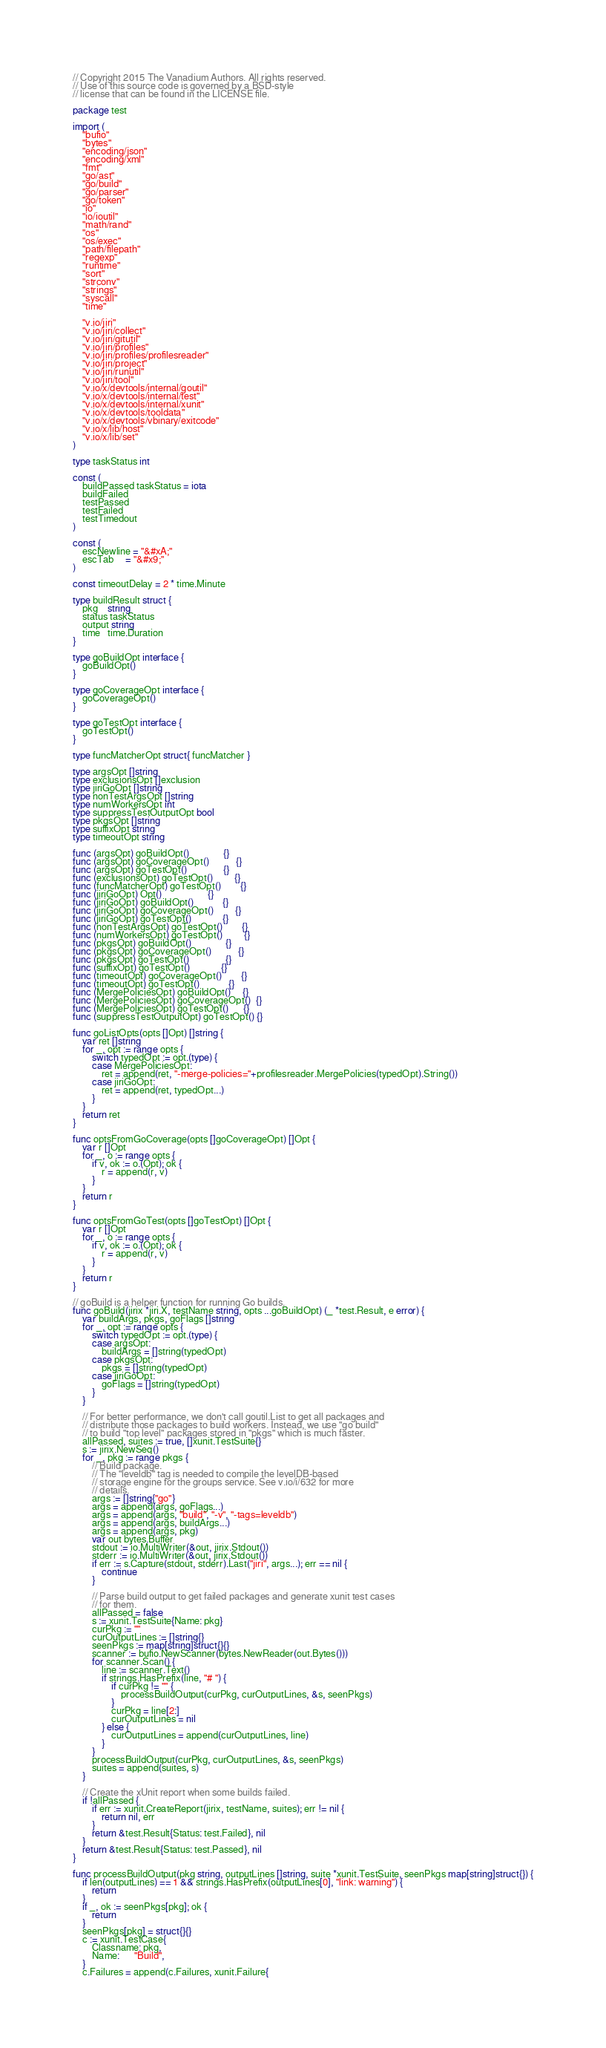<code> <loc_0><loc_0><loc_500><loc_500><_Go_>// Copyright 2015 The Vanadium Authors. All rights reserved.
// Use of this source code is governed by a BSD-style
// license that can be found in the LICENSE file.

package test

import (
	"bufio"
	"bytes"
	"encoding/json"
	"encoding/xml"
	"fmt"
	"go/ast"
	"go/build"
	"go/parser"
	"go/token"
	"io"
	"io/ioutil"
	"math/rand"
	"os"
	"os/exec"
	"path/filepath"
	"regexp"
	"runtime"
	"sort"
	"strconv"
	"strings"
	"syscall"
	"time"

	"v.io/jiri"
	"v.io/jiri/collect"
	"v.io/jiri/gitutil"
	"v.io/jiri/profiles"
	"v.io/jiri/profiles/profilesreader"
	"v.io/jiri/project"
	"v.io/jiri/runutil"
	"v.io/jiri/tool"
	"v.io/x/devtools/internal/goutil"
	"v.io/x/devtools/internal/test"
	"v.io/x/devtools/internal/xunit"
	"v.io/x/devtools/tooldata"
	"v.io/x/devtools/vbinary/exitcode"
	"v.io/x/lib/host"
	"v.io/x/lib/set"
)

type taskStatus int

const (
	buildPassed taskStatus = iota
	buildFailed
	testPassed
	testFailed
	testTimedout
)

const (
	escNewline = "&#xA;"
	escTab     = "&#x9;"
)

const timeoutDelay = 2 * time.Minute

type buildResult struct {
	pkg    string
	status taskStatus
	output string
	time   time.Duration
}

type goBuildOpt interface {
	goBuildOpt()
}

type goCoverageOpt interface {
	goCoverageOpt()
}

type goTestOpt interface {
	goTestOpt()
}

type funcMatcherOpt struct{ funcMatcher }

type argsOpt []string
type exclusionsOpt []exclusion
type jiriGoOpt []string
type nonTestArgsOpt []string
type numWorkersOpt int
type suppressTestOutputOpt bool
type pkgsOpt []string
type suffixOpt string
type timeoutOpt string

func (argsOpt) goBuildOpt()              {}
func (argsOpt) goCoverageOpt()           {}
func (argsOpt) goTestOpt()               {}
func (exclusionsOpt) goTestOpt()         {}
func (funcMatcherOpt) goTestOpt()        {}
func (jiriGoOpt) Opt()                   {}
func (jiriGoOpt) goBuildOpt()            {}
func (jiriGoOpt) goCoverageOpt()         {}
func (jiriGoOpt) goTestOpt()             {}
func (nonTestArgsOpt) goTestOpt()        {}
func (numWorkersOpt) goTestOpt()         {}
func (pkgsOpt) goBuildOpt()              {}
func (pkgsOpt) goCoverageOpt()           {}
func (pkgsOpt) goTestOpt()               {}
func (suffixOpt) goTestOpt()             {}
func (timeoutOpt) goCoverageOpt()        {}
func (timeoutOpt) goTestOpt()            {}
func (MergePoliciesOpt) goBuildOpt()     {}
func (MergePoliciesOpt) goCoverageOpt()  {}
func (MergePoliciesOpt) goTestOpt()      {}
func (suppressTestOutputOpt) goTestOpt() {}

func goListOpts(opts []Opt) []string {
	var ret []string
	for _, opt := range opts {
		switch typedOpt := opt.(type) {
		case MergePoliciesOpt:
			ret = append(ret, "-merge-policies="+profilesreader.MergePolicies(typedOpt).String())
		case jiriGoOpt:
			ret = append(ret, typedOpt...)
		}
	}
	return ret
}

func optsFromGoCoverage(opts []goCoverageOpt) []Opt {
	var r []Opt
	for _, o := range opts {
		if v, ok := o.(Opt); ok {
			r = append(r, v)
		}
	}
	return r
}

func optsFromGoTest(opts []goTestOpt) []Opt {
	var r []Opt
	for _, o := range opts {
		if v, ok := o.(Opt); ok {
			r = append(r, v)
		}
	}
	return r
}

// goBuild is a helper function for running Go builds.
func goBuild(jirix *jiri.X, testName string, opts ...goBuildOpt) (_ *test.Result, e error) {
	var buildArgs, pkgs, goFlags []string
	for _, opt := range opts {
		switch typedOpt := opt.(type) {
		case argsOpt:
			buildArgs = []string(typedOpt)
		case pkgsOpt:
			pkgs = []string(typedOpt)
		case jiriGoOpt:
			goFlags = []string(typedOpt)
		}
	}

	// For better performance, we don't call goutil.List to get all packages and
	// distribute those packages to build workers. Instead, we use "go build"
	// to build "top level" packages stored in "pkgs" which is much faster.
	allPassed, suites := true, []xunit.TestSuite{}
	s := jirix.NewSeq()
	for _, pkg := range pkgs {
		// Build package.
		// The "leveldb" tag is needed to compile the levelDB-based
		// storage engine for the groups service. See v.io/i/632 for more
		// details.
		args := []string{"go"}
		args = append(args, goFlags...)
		args = append(args, "build", "-v", "-tags=leveldb")
		args = append(args, buildArgs...)
		args = append(args, pkg)
		var out bytes.Buffer
		stdout := io.MultiWriter(&out, jirix.Stdout())
		stderr := io.MultiWriter(&out, jirix.Stdout())
		if err := s.Capture(stdout, stderr).Last("jiri", args...); err == nil {
			continue
		}

		// Parse build output to get failed packages and generate xunit test cases
		// for them.
		allPassed = false
		s := xunit.TestSuite{Name: pkg}
		curPkg := ""
		curOutputLines := []string{}
		seenPkgs := map[string]struct{}{}
		scanner := bufio.NewScanner(bytes.NewReader(out.Bytes()))
		for scanner.Scan() {
			line := scanner.Text()
			if strings.HasPrefix(line, "# ") {
				if curPkg != "" {
					processBuildOutput(curPkg, curOutputLines, &s, seenPkgs)
				}
				curPkg = line[2:]
				curOutputLines = nil
			} else {
				curOutputLines = append(curOutputLines, line)
			}
		}
		processBuildOutput(curPkg, curOutputLines, &s, seenPkgs)
		suites = append(suites, s)
	}

	// Create the xUnit report when some builds failed.
	if !allPassed {
		if err := xunit.CreateReport(jirix, testName, suites); err != nil {
			return nil, err
		}
		return &test.Result{Status: test.Failed}, nil
	}
	return &test.Result{Status: test.Passed}, nil
}

func processBuildOutput(pkg string, outputLines []string, suite *xunit.TestSuite, seenPkgs map[string]struct{}) {
	if len(outputLines) == 1 && strings.HasPrefix(outputLines[0], "link: warning") {
		return
	}
	if _, ok := seenPkgs[pkg]; ok {
		return
	}
	seenPkgs[pkg] = struct{}{}
	c := xunit.TestCase{
		Classname: pkg,
		Name:      "Build",
	}
	c.Failures = append(c.Failures, xunit.Failure{</code> 